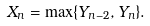<formula> <loc_0><loc_0><loc_500><loc_500>X _ { n } = \max \{ Y _ { n - 2 } , Y _ { n } \} .</formula> 